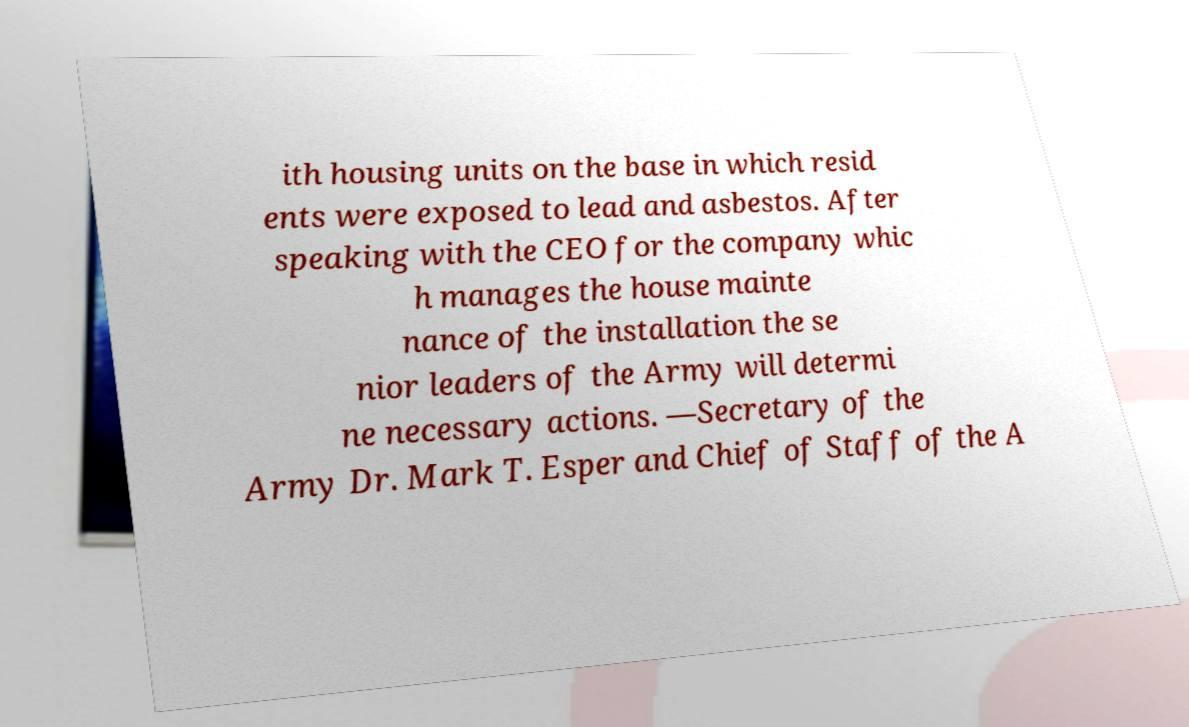For documentation purposes, I need the text within this image transcribed. Could you provide that? ith housing units on the base in which resid ents were exposed to lead and asbestos. After speaking with the CEO for the company whic h manages the house mainte nance of the installation the se nior leaders of the Army will determi ne necessary actions. —Secretary of the Army Dr. Mark T. Esper and Chief of Staff of the A 